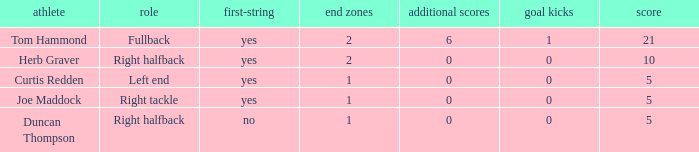What are the most extra points ever scored by a right tackle? 0.0. 